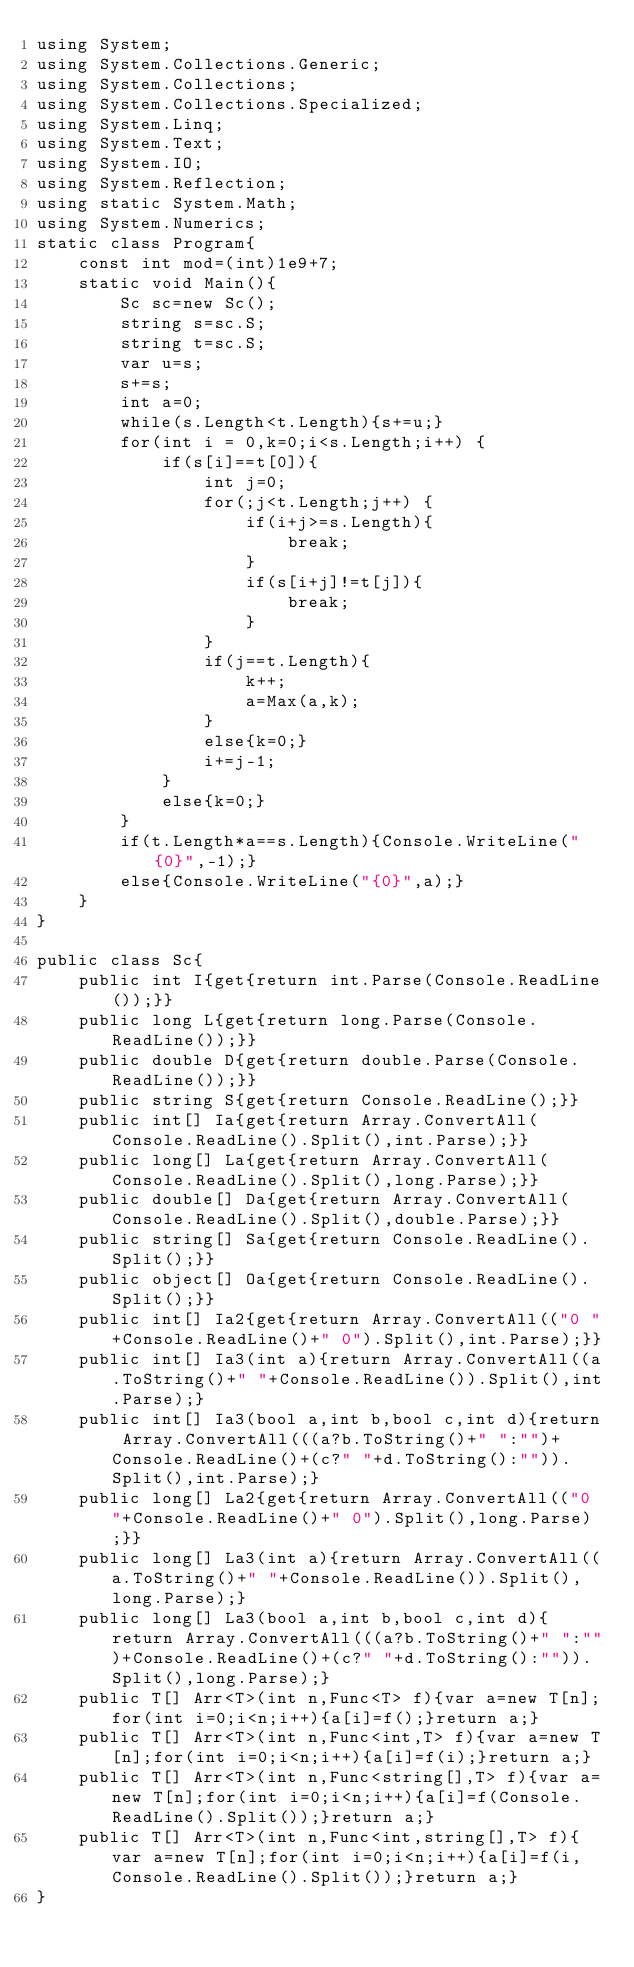Convert code to text. <code><loc_0><loc_0><loc_500><loc_500><_C#_>using System;
using System.Collections.Generic;
using System.Collections;
using System.Collections.Specialized;
using System.Linq;
using System.Text;
using System.IO;
using System.Reflection;
using static System.Math;
using System.Numerics;
static class Program{
	const int mod=(int)1e9+7;
	static void Main(){
		Sc sc=new Sc();
		string s=sc.S;
		string t=sc.S;
		var u=s;
		s+=s;
		int a=0;
		while(s.Length<t.Length){s+=u;}
		for(int i = 0,k=0;i<s.Length;i++) {
			if(s[i]==t[0]){
				int j=0;
				for(;j<t.Length;j++) {
					if(i+j>=s.Length){
						break;
					}
					if(s[i+j]!=t[j]){
						break;
					}
				}
				if(j==t.Length){
					k++;
					a=Max(a,k);
				}
				else{k=0;}
				i+=j-1;
			}
			else{k=0;}
		}
		if(t.Length*a==s.Length){Console.WriteLine("{0}",-1);}
		else{Console.WriteLine("{0}",a);}
	}
}

public class Sc{
	public int I{get{return int.Parse(Console.ReadLine());}}
	public long L{get{return long.Parse(Console.ReadLine());}}
	public double D{get{return double.Parse(Console.ReadLine());}}
	public string S{get{return Console.ReadLine();}}
	public int[] Ia{get{return Array.ConvertAll(Console.ReadLine().Split(),int.Parse);}}
	public long[] La{get{return Array.ConvertAll(Console.ReadLine().Split(),long.Parse);}}
	public double[] Da{get{return Array.ConvertAll(Console.ReadLine().Split(),double.Parse);}}
	public string[] Sa{get{return Console.ReadLine().Split();}}
	public object[] Oa{get{return Console.ReadLine().Split();}}
	public int[] Ia2{get{return Array.ConvertAll(("0 "+Console.ReadLine()+" 0").Split(),int.Parse);}}
	public int[] Ia3(int a){return Array.ConvertAll((a.ToString()+" "+Console.ReadLine()).Split(),int.Parse);}
	public int[] Ia3(bool a,int b,bool c,int d){return Array.ConvertAll(((a?b.ToString()+" ":"")+Console.ReadLine()+(c?" "+d.ToString():"")).Split(),int.Parse);}
	public long[] La2{get{return Array.ConvertAll(("0 "+Console.ReadLine()+" 0").Split(),long.Parse);}}
	public long[] La3(int a){return Array.ConvertAll((a.ToString()+" "+Console.ReadLine()).Split(),long.Parse);}
	public long[] La3(bool a,int b,bool c,int d){return Array.ConvertAll(((a?b.ToString()+" ":"")+Console.ReadLine()+(c?" "+d.ToString():"")).Split(),long.Parse);}
	public T[] Arr<T>(int n,Func<T> f){var a=new T[n];for(int i=0;i<n;i++){a[i]=f();}return a;}
	public T[] Arr<T>(int n,Func<int,T> f){var a=new T[n];for(int i=0;i<n;i++){a[i]=f(i);}return a;}
	public T[] Arr<T>(int n,Func<string[],T> f){var a=new T[n];for(int i=0;i<n;i++){a[i]=f(Console.ReadLine().Split());}return a;}
	public T[] Arr<T>(int n,Func<int,string[],T> f){var a=new T[n];for(int i=0;i<n;i++){a[i]=f(i,Console.ReadLine().Split());}return a;}
}
</code> 